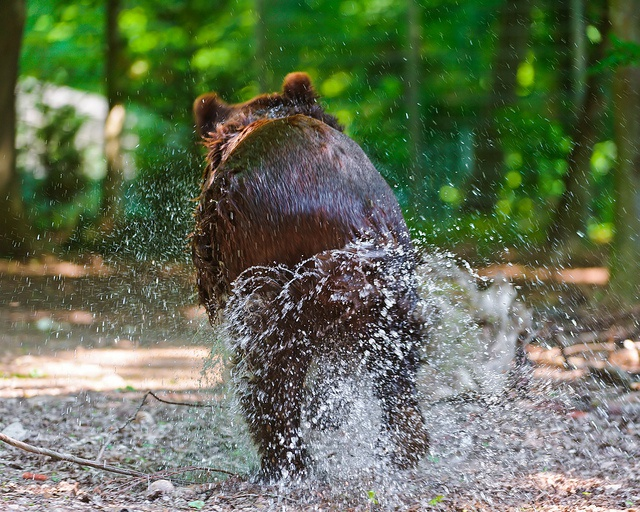Describe the objects in this image and their specific colors. I can see a bear in black, gray, darkgray, and maroon tones in this image. 